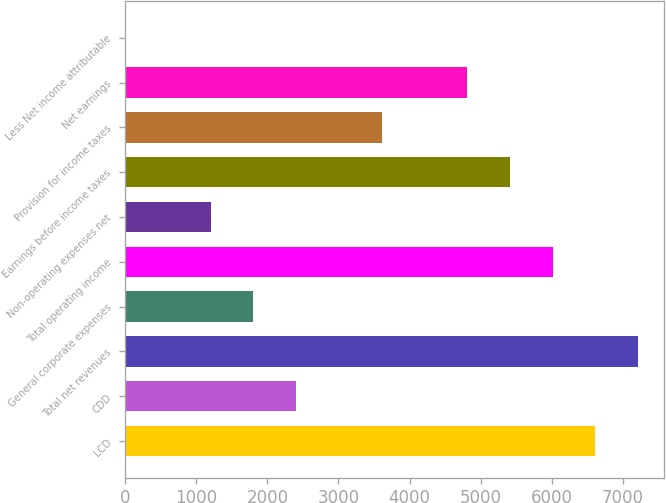Convert chart to OTSL. <chart><loc_0><loc_0><loc_500><loc_500><bar_chart><fcel>LCD<fcel>CDD<fcel>Total net revenues<fcel>General corporate expenses<fcel>Total operating income<fcel>Non-operating expenses net<fcel>Earnings before income taxes<fcel>Provision for income taxes<fcel>Net earnings<fcel>Less Net income attributable<nl><fcel>6612.62<fcel>2405.48<fcel>7213.64<fcel>1804.46<fcel>6011.6<fcel>1203.44<fcel>5410.58<fcel>3607.52<fcel>4809.56<fcel>1.4<nl></chart> 